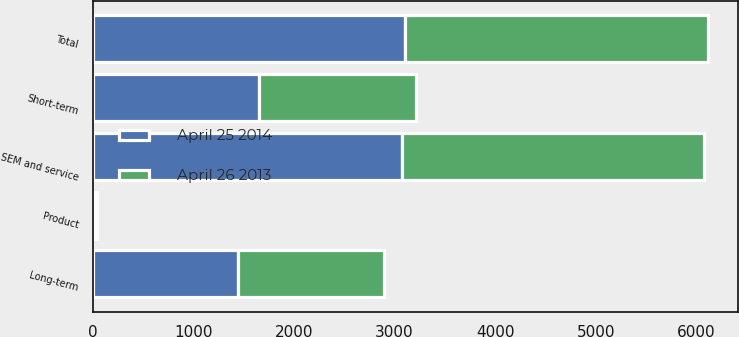Convert chart to OTSL. <chart><loc_0><loc_0><loc_500><loc_500><stacked_bar_chart><ecel><fcel>Product<fcel>SEM and service<fcel>Total<fcel>Short-term<fcel>Long-term<nl><fcel>April 25 2014<fcel>23.4<fcel>3076.8<fcel>3100.2<fcel>1653.8<fcel>1446.4<nl><fcel>April 26 2013<fcel>15.7<fcel>2993.8<fcel>3009.5<fcel>1563.3<fcel>1446.2<nl></chart> 